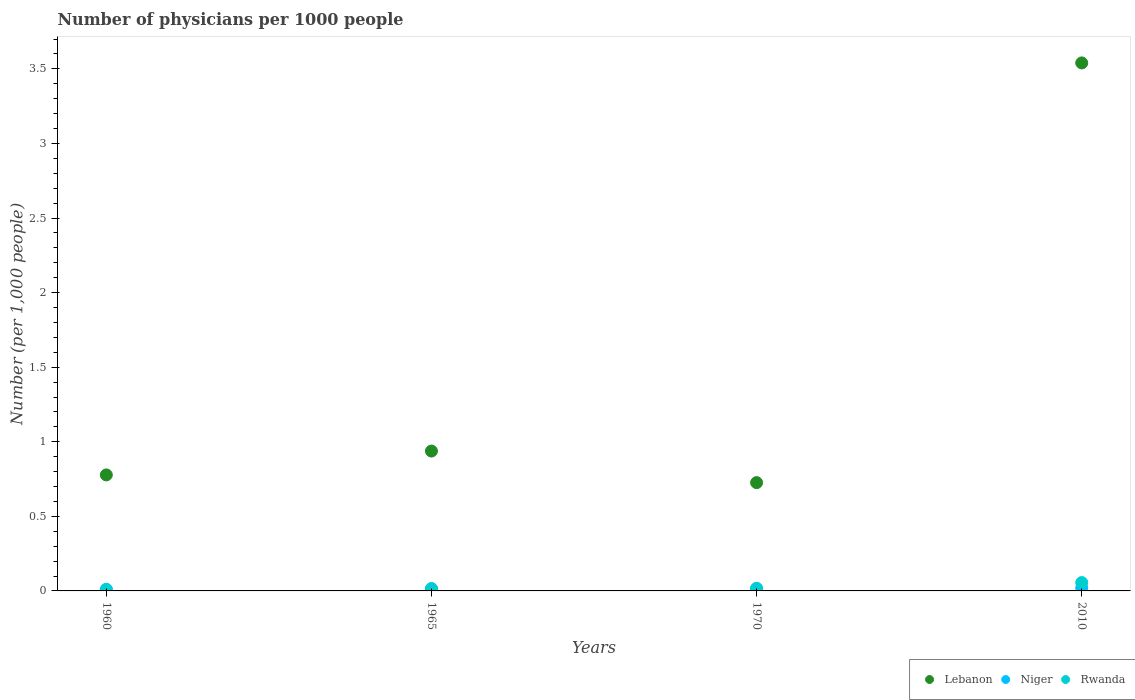How many different coloured dotlines are there?
Provide a short and direct response. 3. What is the number of physicians in Lebanon in 2010?
Offer a very short reply. 3.54. Across all years, what is the maximum number of physicians in Lebanon?
Offer a terse response. 3.54. Across all years, what is the minimum number of physicians in Rwanda?
Keep it short and to the point. 0.01. What is the total number of physicians in Rwanda in the graph?
Provide a short and direct response. 0.09. What is the difference between the number of physicians in Lebanon in 1960 and that in 2010?
Give a very brief answer. -2.76. What is the difference between the number of physicians in Niger in 1960 and the number of physicians in Rwanda in 1970?
Your answer should be compact. -0.01. What is the average number of physicians in Niger per year?
Provide a short and direct response. 0.02. In the year 2010, what is the difference between the number of physicians in Rwanda and number of physicians in Lebanon?
Ensure brevity in your answer.  -3.48. What is the ratio of the number of physicians in Lebanon in 1970 to that in 2010?
Give a very brief answer. 0.21. Is the difference between the number of physicians in Rwanda in 1960 and 1965 greater than the difference between the number of physicians in Lebanon in 1960 and 1965?
Your response must be concise. Yes. What is the difference between the highest and the second highest number of physicians in Rwanda?
Make the answer very short. 0.04. What is the difference between the highest and the lowest number of physicians in Lebanon?
Ensure brevity in your answer.  2.81. In how many years, is the number of physicians in Rwanda greater than the average number of physicians in Rwanda taken over all years?
Make the answer very short. 1. Is it the case that in every year, the sum of the number of physicians in Lebanon and number of physicians in Niger  is greater than the number of physicians in Rwanda?
Your response must be concise. Yes. Does the number of physicians in Lebanon monotonically increase over the years?
Offer a very short reply. No. Is the number of physicians in Rwanda strictly less than the number of physicians in Lebanon over the years?
Offer a very short reply. Yes. Are the values on the major ticks of Y-axis written in scientific E-notation?
Make the answer very short. No. Does the graph contain any zero values?
Ensure brevity in your answer.  No. Does the graph contain grids?
Provide a short and direct response. No. Where does the legend appear in the graph?
Your answer should be very brief. Bottom right. How many legend labels are there?
Provide a succinct answer. 3. What is the title of the graph?
Your answer should be compact. Number of physicians per 1000 people. What is the label or title of the Y-axis?
Ensure brevity in your answer.  Number (per 1,0 people). What is the Number (per 1,000 people) in Lebanon in 1960?
Your answer should be compact. 0.78. What is the Number (per 1,000 people) of Niger in 1960?
Ensure brevity in your answer.  0.01. What is the Number (per 1,000 people) in Rwanda in 1960?
Your answer should be compact. 0.01. What is the Number (per 1,000 people) of Lebanon in 1965?
Make the answer very short. 0.94. What is the Number (per 1,000 people) of Niger in 1965?
Offer a terse response. 0.02. What is the Number (per 1,000 people) of Rwanda in 1965?
Keep it short and to the point. 0.01. What is the Number (per 1,000 people) in Lebanon in 1970?
Make the answer very short. 0.73. What is the Number (per 1,000 people) of Niger in 1970?
Keep it short and to the point. 0.02. What is the Number (per 1,000 people) in Rwanda in 1970?
Provide a short and direct response. 0.02. What is the Number (per 1,000 people) of Lebanon in 2010?
Make the answer very short. 3.54. What is the Number (per 1,000 people) in Niger in 2010?
Provide a succinct answer. 0.02. What is the Number (per 1,000 people) in Rwanda in 2010?
Your response must be concise. 0.06. Across all years, what is the maximum Number (per 1,000 people) of Lebanon?
Keep it short and to the point. 3.54. Across all years, what is the maximum Number (per 1,000 people) in Niger?
Your answer should be compact. 0.02. Across all years, what is the maximum Number (per 1,000 people) of Rwanda?
Provide a succinct answer. 0.06. Across all years, what is the minimum Number (per 1,000 people) of Lebanon?
Provide a short and direct response. 0.73. Across all years, what is the minimum Number (per 1,000 people) in Niger?
Keep it short and to the point. 0.01. Across all years, what is the minimum Number (per 1,000 people) of Rwanda?
Provide a succinct answer. 0.01. What is the total Number (per 1,000 people) of Lebanon in the graph?
Offer a terse response. 5.98. What is the total Number (per 1,000 people) of Niger in the graph?
Offer a very short reply. 0.06. What is the total Number (per 1,000 people) of Rwanda in the graph?
Ensure brevity in your answer.  0.09. What is the difference between the Number (per 1,000 people) of Lebanon in 1960 and that in 1965?
Provide a succinct answer. -0.16. What is the difference between the Number (per 1,000 people) in Niger in 1960 and that in 1965?
Provide a short and direct response. -0. What is the difference between the Number (per 1,000 people) of Rwanda in 1960 and that in 1965?
Keep it short and to the point. -0.01. What is the difference between the Number (per 1,000 people) of Lebanon in 1960 and that in 1970?
Your answer should be compact. 0.05. What is the difference between the Number (per 1,000 people) in Niger in 1960 and that in 1970?
Provide a short and direct response. -0.01. What is the difference between the Number (per 1,000 people) of Rwanda in 1960 and that in 1970?
Provide a short and direct response. -0.01. What is the difference between the Number (per 1,000 people) in Lebanon in 1960 and that in 2010?
Your answer should be very brief. -2.76. What is the difference between the Number (per 1,000 people) of Niger in 1960 and that in 2010?
Ensure brevity in your answer.  -0.01. What is the difference between the Number (per 1,000 people) of Rwanda in 1960 and that in 2010?
Give a very brief answer. -0.05. What is the difference between the Number (per 1,000 people) of Lebanon in 1965 and that in 1970?
Ensure brevity in your answer.  0.21. What is the difference between the Number (per 1,000 people) in Niger in 1965 and that in 1970?
Make the answer very short. -0. What is the difference between the Number (per 1,000 people) in Rwanda in 1965 and that in 1970?
Provide a succinct answer. -0. What is the difference between the Number (per 1,000 people) in Lebanon in 1965 and that in 2010?
Provide a short and direct response. -2.6. What is the difference between the Number (per 1,000 people) in Niger in 1965 and that in 2010?
Provide a succinct answer. -0. What is the difference between the Number (per 1,000 people) of Rwanda in 1965 and that in 2010?
Provide a short and direct response. -0.04. What is the difference between the Number (per 1,000 people) of Lebanon in 1970 and that in 2010?
Your answer should be compact. -2.81. What is the difference between the Number (per 1,000 people) of Niger in 1970 and that in 2010?
Offer a terse response. -0. What is the difference between the Number (per 1,000 people) in Rwanda in 1970 and that in 2010?
Give a very brief answer. -0.04. What is the difference between the Number (per 1,000 people) in Lebanon in 1960 and the Number (per 1,000 people) in Niger in 1965?
Provide a succinct answer. 0.76. What is the difference between the Number (per 1,000 people) in Lebanon in 1960 and the Number (per 1,000 people) in Rwanda in 1965?
Offer a terse response. 0.76. What is the difference between the Number (per 1,000 people) of Niger in 1960 and the Number (per 1,000 people) of Rwanda in 1965?
Offer a very short reply. -0. What is the difference between the Number (per 1,000 people) in Lebanon in 1960 and the Number (per 1,000 people) in Niger in 1970?
Offer a very short reply. 0.76. What is the difference between the Number (per 1,000 people) of Lebanon in 1960 and the Number (per 1,000 people) of Rwanda in 1970?
Give a very brief answer. 0.76. What is the difference between the Number (per 1,000 people) of Niger in 1960 and the Number (per 1,000 people) of Rwanda in 1970?
Keep it short and to the point. -0.01. What is the difference between the Number (per 1,000 people) of Lebanon in 1960 and the Number (per 1,000 people) of Niger in 2010?
Keep it short and to the point. 0.76. What is the difference between the Number (per 1,000 people) of Lebanon in 1960 and the Number (per 1,000 people) of Rwanda in 2010?
Give a very brief answer. 0.72. What is the difference between the Number (per 1,000 people) of Niger in 1960 and the Number (per 1,000 people) of Rwanda in 2010?
Ensure brevity in your answer.  -0.04. What is the difference between the Number (per 1,000 people) of Lebanon in 1965 and the Number (per 1,000 people) of Niger in 1970?
Offer a terse response. 0.92. What is the difference between the Number (per 1,000 people) of Lebanon in 1965 and the Number (per 1,000 people) of Rwanda in 1970?
Your answer should be very brief. 0.92. What is the difference between the Number (per 1,000 people) of Niger in 1965 and the Number (per 1,000 people) of Rwanda in 1970?
Give a very brief answer. -0. What is the difference between the Number (per 1,000 people) in Lebanon in 1965 and the Number (per 1,000 people) in Niger in 2010?
Ensure brevity in your answer.  0.92. What is the difference between the Number (per 1,000 people) of Lebanon in 1965 and the Number (per 1,000 people) of Rwanda in 2010?
Provide a short and direct response. 0.88. What is the difference between the Number (per 1,000 people) of Niger in 1965 and the Number (per 1,000 people) of Rwanda in 2010?
Ensure brevity in your answer.  -0.04. What is the difference between the Number (per 1,000 people) of Lebanon in 1970 and the Number (per 1,000 people) of Niger in 2010?
Your response must be concise. 0.71. What is the difference between the Number (per 1,000 people) in Lebanon in 1970 and the Number (per 1,000 people) in Rwanda in 2010?
Ensure brevity in your answer.  0.67. What is the difference between the Number (per 1,000 people) in Niger in 1970 and the Number (per 1,000 people) in Rwanda in 2010?
Your answer should be very brief. -0.04. What is the average Number (per 1,000 people) of Lebanon per year?
Offer a very short reply. 1.5. What is the average Number (per 1,000 people) of Niger per year?
Your answer should be compact. 0.02. What is the average Number (per 1,000 people) of Rwanda per year?
Your response must be concise. 0.02. In the year 1960, what is the difference between the Number (per 1,000 people) of Lebanon and Number (per 1,000 people) of Niger?
Your answer should be very brief. 0.77. In the year 1960, what is the difference between the Number (per 1,000 people) of Lebanon and Number (per 1,000 people) of Rwanda?
Keep it short and to the point. 0.77. In the year 1960, what is the difference between the Number (per 1,000 people) in Niger and Number (per 1,000 people) in Rwanda?
Your answer should be compact. 0. In the year 1965, what is the difference between the Number (per 1,000 people) in Lebanon and Number (per 1,000 people) in Niger?
Provide a short and direct response. 0.92. In the year 1965, what is the difference between the Number (per 1,000 people) of Lebanon and Number (per 1,000 people) of Rwanda?
Ensure brevity in your answer.  0.92. In the year 1965, what is the difference between the Number (per 1,000 people) of Niger and Number (per 1,000 people) of Rwanda?
Provide a succinct answer. 0. In the year 1970, what is the difference between the Number (per 1,000 people) in Lebanon and Number (per 1,000 people) in Niger?
Offer a very short reply. 0.71. In the year 1970, what is the difference between the Number (per 1,000 people) in Lebanon and Number (per 1,000 people) in Rwanda?
Ensure brevity in your answer.  0.71. In the year 2010, what is the difference between the Number (per 1,000 people) of Lebanon and Number (per 1,000 people) of Niger?
Your answer should be very brief. 3.52. In the year 2010, what is the difference between the Number (per 1,000 people) in Lebanon and Number (per 1,000 people) in Rwanda?
Give a very brief answer. 3.48. In the year 2010, what is the difference between the Number (per 1,000 people) in Niger and Number (per 1,000 people) in Rwanda?
Offer a terse response. -0.04. What is the ratio of the Number (per 1,000 people) in Lebanon in 1960 to that in 1965?
Provide a succinct answer. 0.83. What is the ratio of the Number (per 1,000 people) of Niger in 1960 to that in 1965?
Provide a short and direct response. 0.7. What is the ratio of the Number (per 1,000 people) in Rwanda in 1960 to that in 1965?
Give a very brief answer. 0.55. What is the ratio of the Number (per 1,000 people) of Lebanon in 1960 to that in 1970?
Your response must be concise. 1.07. What is the ratio of the Number (per 1,000 people) of Niger in 1960 to that in 1970?
Provide a succinct answer. 0.66. What is the ratio of the Number (per 1,000 people) of Rwanda in 1960 to that in 1970?
Your response must be concise. 0.46. What is the ratio of the Number (per 1,000 people) in Lebanon in 1960 to that in 2010?
Give a very brief answer. 0.22. What is the ratio of the Number (per 1,000 people) of Niger in 1960 to that in 2010?
Give a very brief answer. 0.58. What is the ratio of the Number (per 1,000 people) of Rwanda in 1960 to that in 2010?
Your response must be concise. 0.14. What is the ratio of the Number (per 1,000 people) of Lebanon in 1965 to that in 1970?
Your answer should be compact. 1.29. What is the ratio of the Number (per 1,000 people) of Niger in 1965 to that in 1970?
Give a very brief answer. 0.95. What is the ratio of the Number (per 1,000 people) of Rwanda in 1965 to that in 1970?
Your answer should be very brief. 0.83. What is the ratio of the Number (per 1,000 people) of Lebanon in 1965 to that in 2010?
Give a very brief answer. 0.26. What is the ratio of the Number (per 1,000 people) in Niger in 1965 to that in 2010?
Your response must be concise. 0.83. What is the ratio of the Number (per 1,000 people) in Rwanda in 1965 to that in 2010?
Your response must be concise. 0.25. What is the ratio of the Number (per 1,000 people) in Lebanon in 1970 to that in 2010?
Give a very brief answer. 0.21. What is the ratio of the Number (per 1,000 people) of Niger in 1970 to that in 2010?
Provide a succinct answer. 0.87. What is the ratio of the Number (per 1,000 people) of Rwanda in 1970 to that in 2010?
Offer a terse response. 0.3. What is the difference between the highest and the second highest Number (per 1,000 people) in Lebanon?
Your answer should be very brief. 2.6. What is the difference between the highest and the second highest Number (per 1,000 people) of Niger?
Your response must be concise. 0. What is the difference between the highest and the second highest Number (per 1,000 people) in Rwanda?
Provide a short and direct response. 0.04. What is the difference between the highest and the lowest Number (per 1,000 people) of Lebanon?
Your answer should be very brief. 2.81. What is the difference between the highest and the lowest Number (per 1,000 people) in Niger?
Keep it short and to the point. 0.01. What is the difference between the highest and the lowest Number (per 1,000 people) of Rwanda?
Make the answer very short. 0.05. 